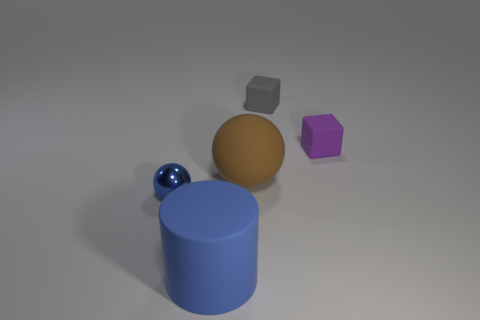Is there any other thing that has the same material as the tiny blue ball?
Your answer should be compact. No. Is the tiny gray object made of the same material as the ball behind the small blue sphere?
Give a very brief answer. Yes. The big matte cylinder is what color?
Your answer should be very brief. Blue. What shape is the matte thing in front of the tiny blue metal sphere?
Keep it short and to the point. Cylinder. How many green things are either shiny things or tiny matte cylinders?
Give a very brief answer. 0. There is a big cylinder that is made of the same material as the brown object; what is its color?
Your response must be concise. Blue. Do the cylinder and the small object that is left of the brown ball have the same color?
Provide a short and direct response. Yes. The tiny object that is on the right side of the big blue cylinder and on the left side of the tiny purple matte block is what color?
Offer a very short reply. Gray. There is a gray cube; how many blocks are on the right side of it?
Your response must be concise. 1. What number of things are either large gray matte balls or tiny gray blocks that are to the right of the brown thing?
Your answer should be very brief. 1. 